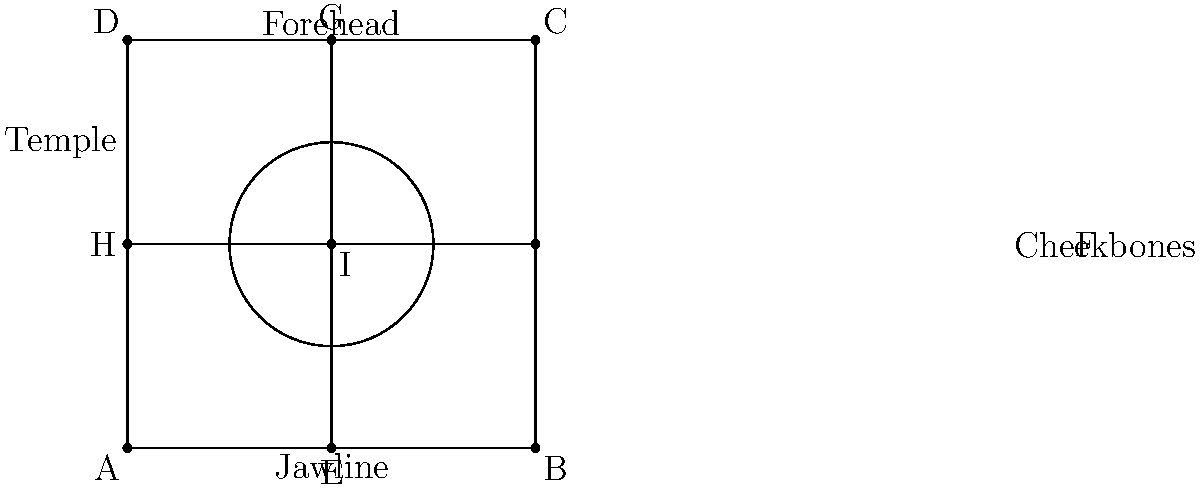As a makeup artist, you're planning to contour a client's face. Using the face diagram provided, which area would you typically apply a darker shade to create the illusion of a more defined facial structure, and what is the general rule for contouring this area in relation to points E and G? To answer this question, let's break down the contouring process and facial anatomy:

1. The diagram shows a simplified face shape divided into sections.
2. In contouring, we aim to create depth and definition by applying darker shades to recessed areas and highlighting prominent areas.
3. The cheekbones are a key area for contouring, typically located between points E (middle of the jawline) and G (middle of the forehead).
4. To create a more defined facial structure, we apply a darker shade below the cheekbones.
5. The general rule for contouring this area is to follow the natural shadow that would be cast if light were shining directly on the face from the front.
6. This shadow typically falls at an angle, starting from just below the ear (near point H) and angling downward towards the corner of the mouth (between points E and I).
7. The contour should be blended carefully to avoid harsh lines, creating a natural-looking shadow effect.
8. By applying the darker shade in this area and blending properly, we create the illusion of more pronounced cheekbones and a more sculpted face shape.
Answer: Below the cheekbones, angling from ear towards mouth 